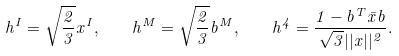Convert formula to latex. <formula><loc_0><loc_0><loc_500><loc_500>h ^ { I } = \sqrt { \frac { 2 } { 3 } } x ^ { I } , \quad h ^ { M } = \sqrt { \frac { 2 } { 3 } } b ^ { M } , \quad h ^ { 4 } = \frac { 1 - b ^ { T } \bar { x } b } { \sqrt { 3 } | | x | | ^ { 2 } } .</formula> 